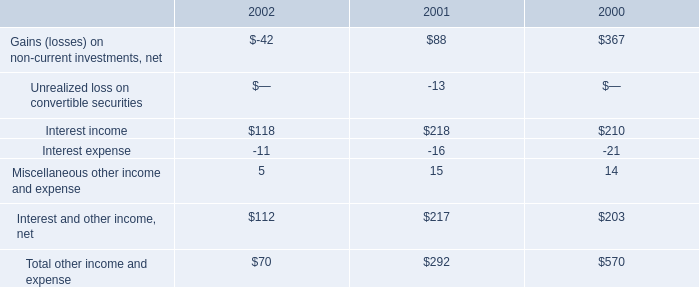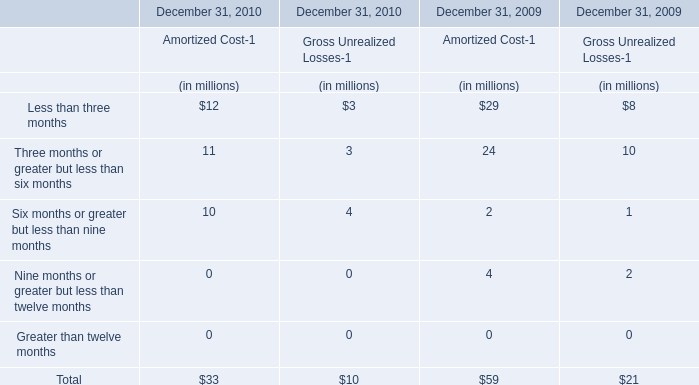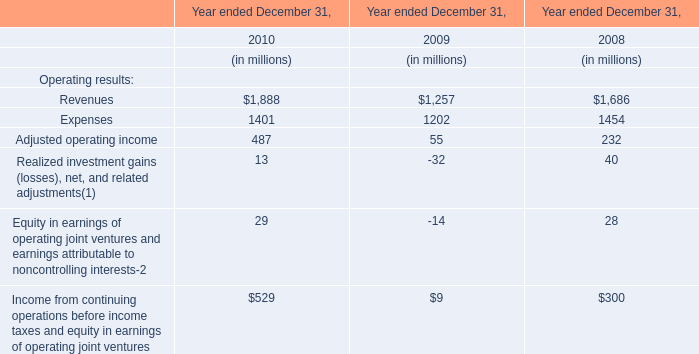Which year is Less than three months for Amortized Cost-1 greater than 2500 ? 
Answer: 2010. 